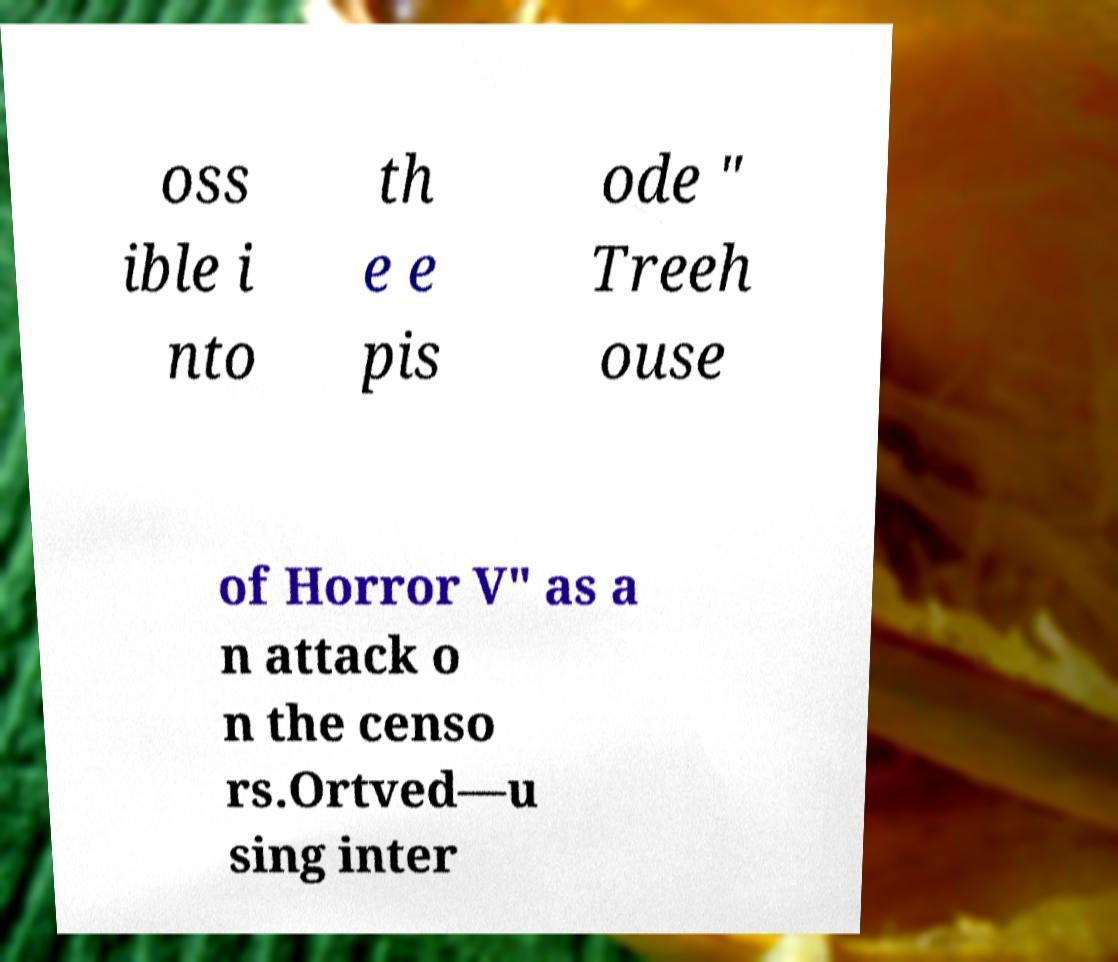For documentation purposes, I need the text within this image transcribed. Could you provide that? oss ible i nto th e e pis ode " Treeh ouse of Horror V" as a n attack o n the censo rs.Ortved—u sing inter 